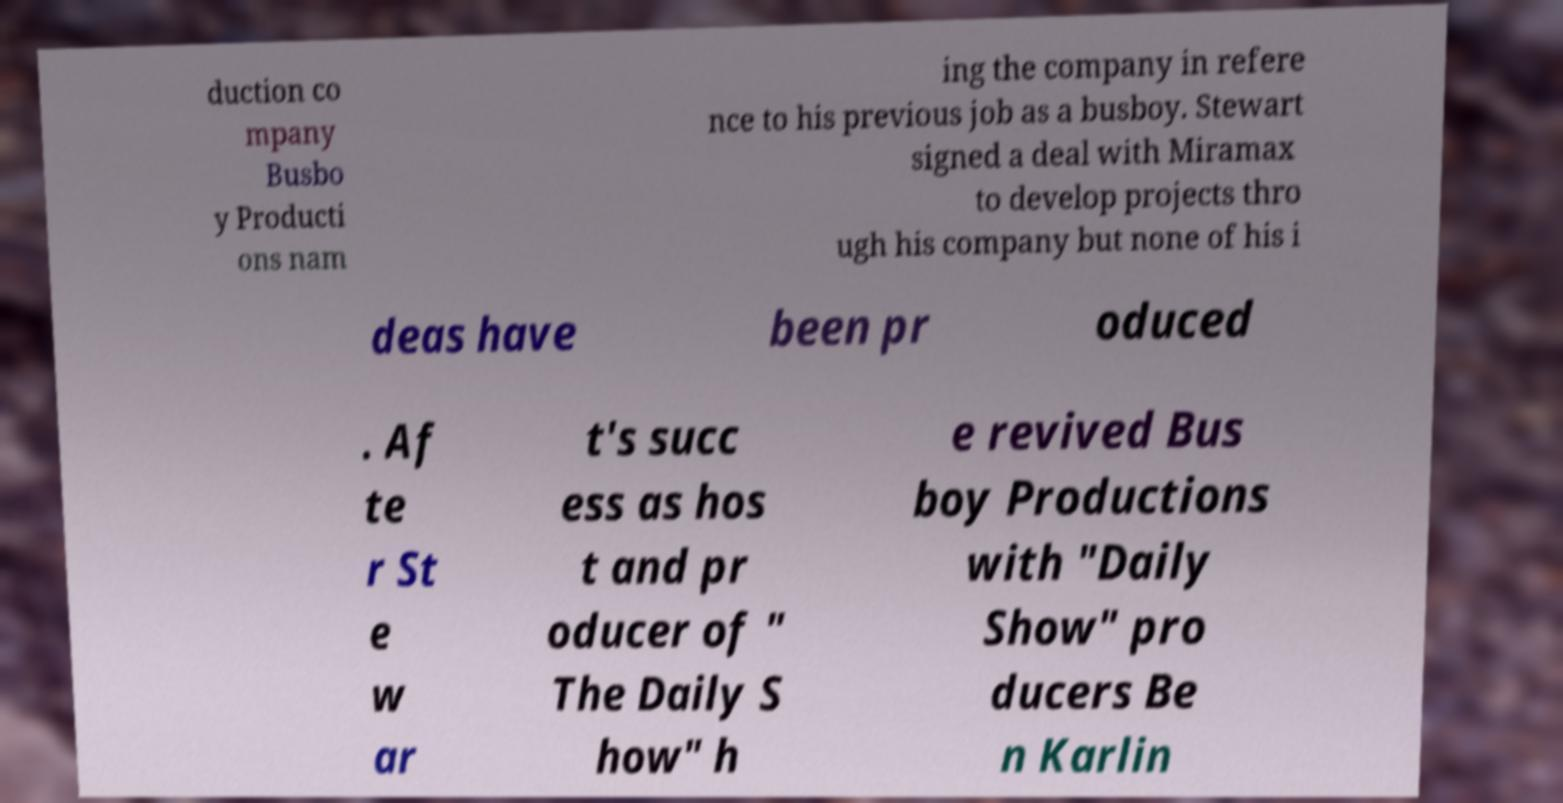Can you accurately transcribe the text from the provided image for me? duction co mpany Busbo y Producti ons nam ing the company in refere nce to his previous job as a busboy. Stewart signed a deal with Miramax to develop projects thro ugh his company but none of his i deas have been pr oduced . Af te r St e w ar t's succ ess as hos t and pr oducer of " The Daily S how" h e revived Bus boy Productions with "Daily Show" pro ducers Be n Karlin 